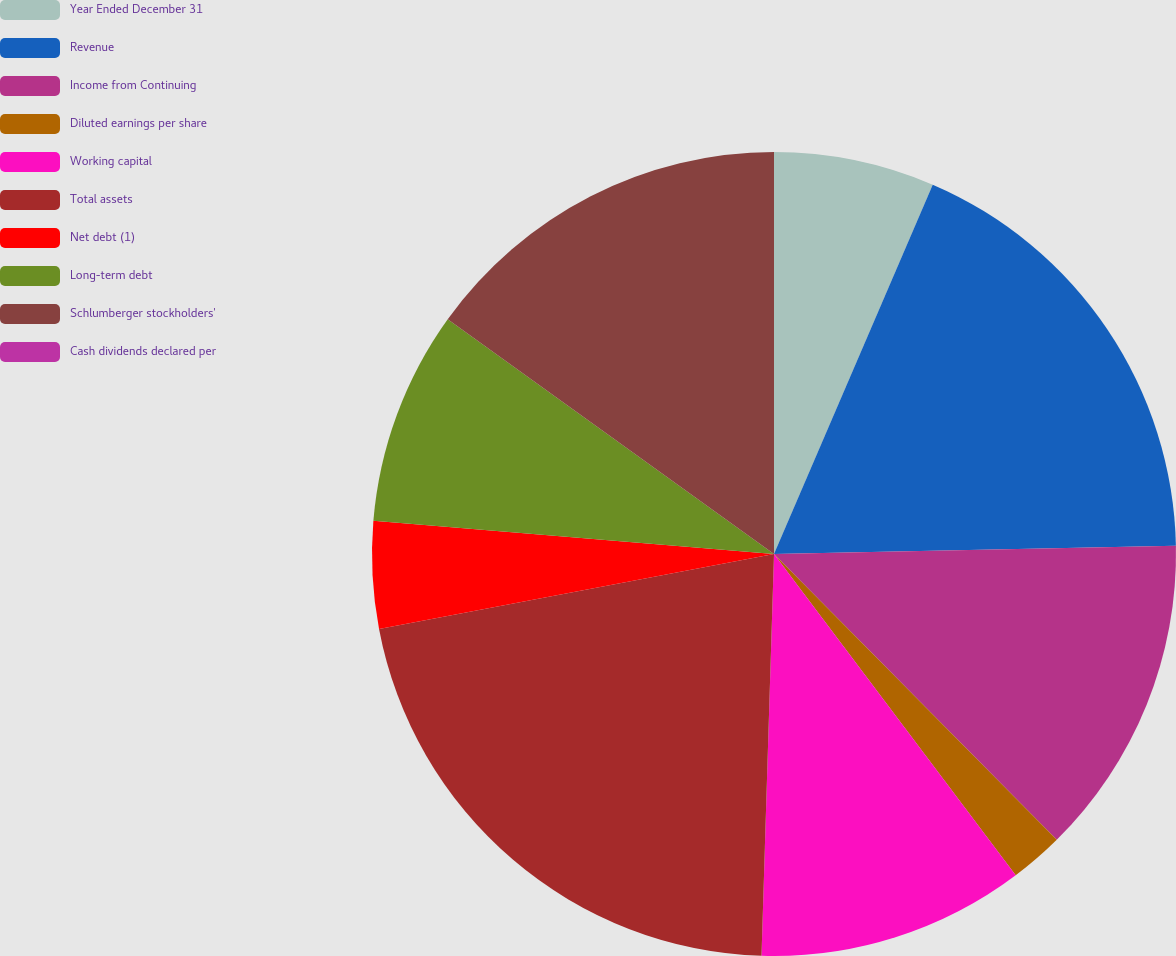Convert chart to OTSL. <chart><loc_0><loc_0><loc_500><loc_500><pie_chart><fcel>Year Ended December 31<fcel>Revenue<fcel>Income from Continuing<fcel>Diluted earnings per share<fcel>Working capital<fcel>Total assets<fcel>Net debt (1)<fcel>Long-term debt<fcel>Schlumberger stockholders'<fcel>Cash dividends declared per<nl><fcel>6.46%<fcel>18.21%<fcel>12.91%<fcel>2.15%<fcel>10.76%<fcel>21.52%<fcel>4.3%<fcel>8.61%<fcel>15.07%<fcel>0.0%<nl></chart> 